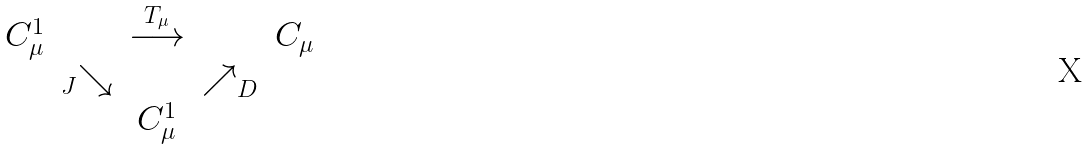Convert formula to latex. <formula><loc_0><loc_0><loc_500><loc_500>\begin{array} [ c ] { c c c c c } C ^ { 1 } _ { \mu } & & \stackrel { T _ { \mu } } \longrightarrow & & C _ { \mu } \\ & { _ { J } } { \searrow } & & { \nearrow } _ { D } \\ & & C ^ { 1 } _ { \mu } \end{array}</formula> 